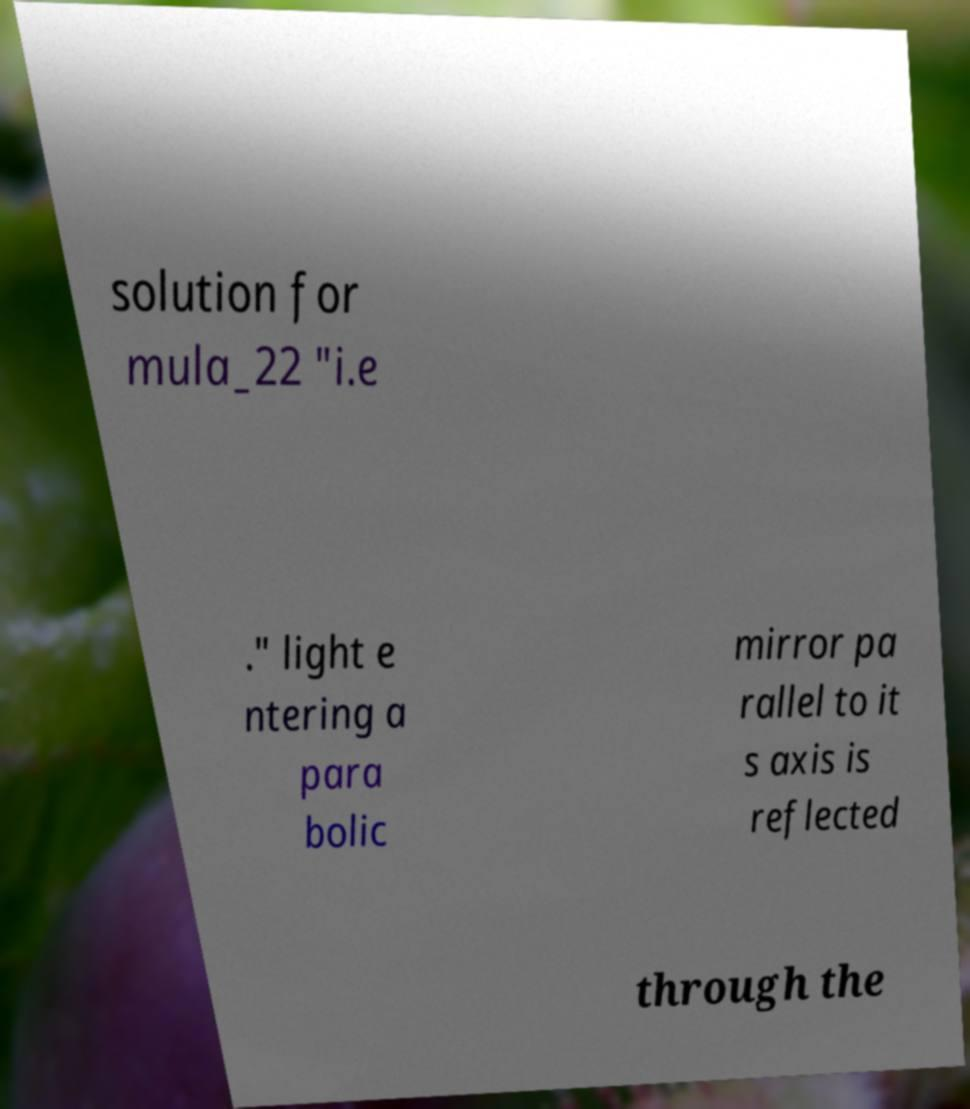There's text embedded in this image that I need extracted. Can you transcribe it verbatim? solution for mula_22 "i.e ." light e ntering a para bolic mirror pa rallel to it s axis is reflected through the 